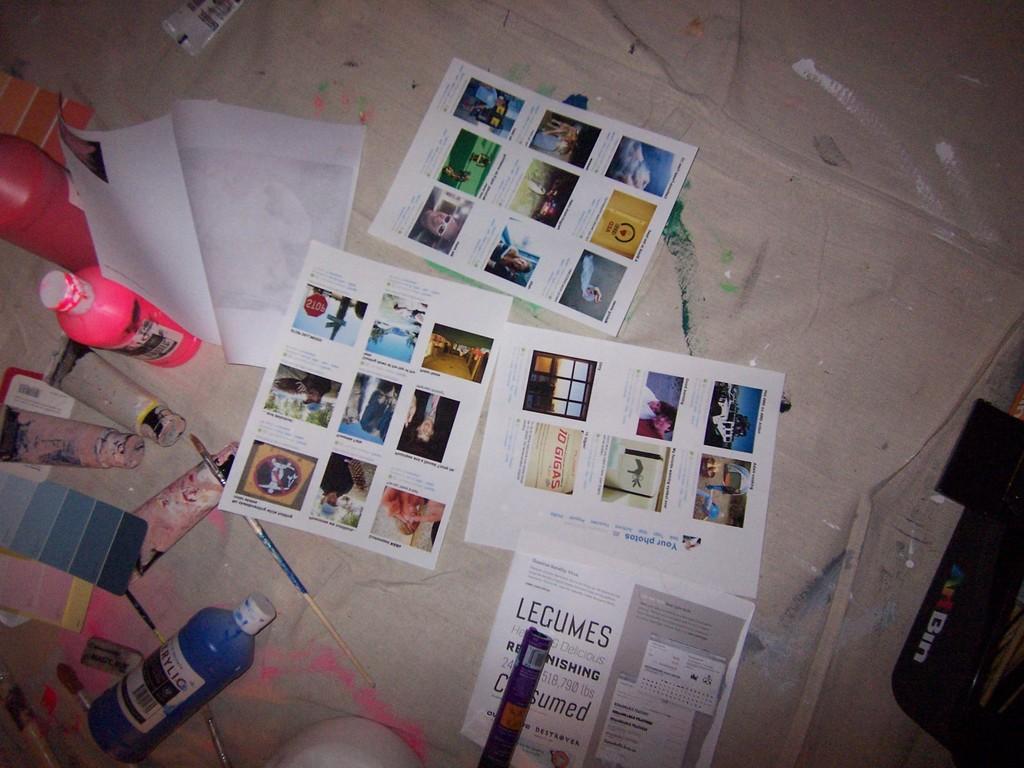What are the papers about?
Make the answer very short. Legumes. What does the bottom text say?
Your answer should be very brief. Legumes. 